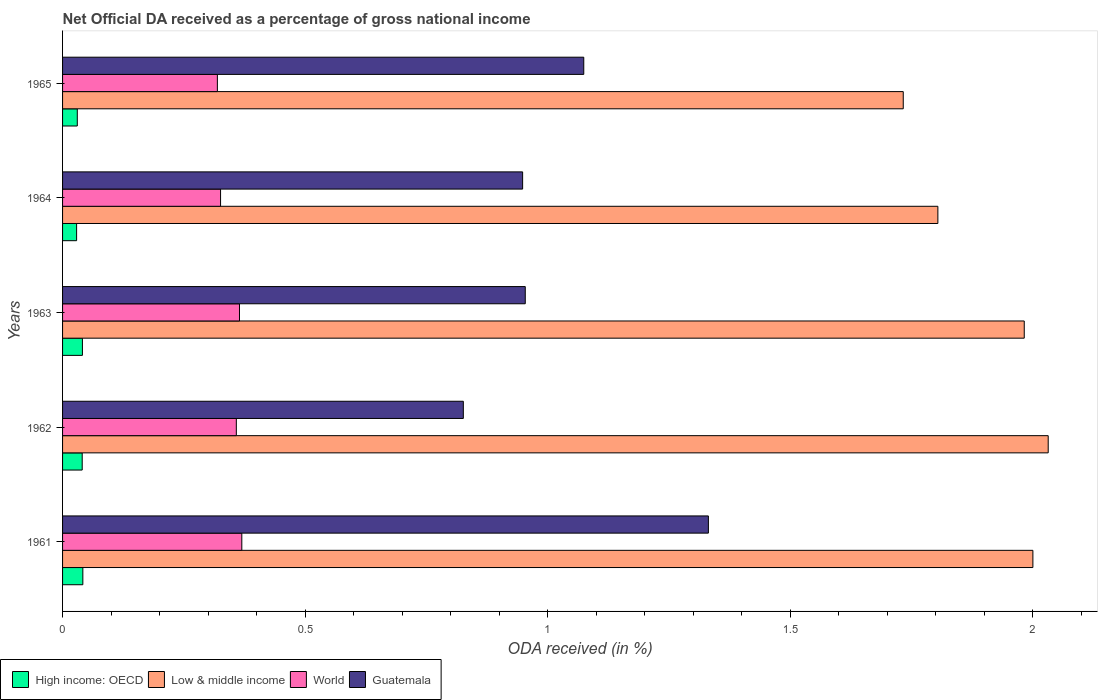How many bars are there on the 4th tick from the bottom?
Keep it short and to the point. 4. What is the label of the 5th group of bars from the top?
Your answer should be very brief. 1961. What is the net official DA received in High income: OECD in 1962?
Offer a very short reply. 0.04. Across all years, what is the maximum net official DA received in World?
Make the answer very short. 0.37. Across all years, what is the minimum net official DA received in Guatemala?
Ensure brevity in your answer.  0.83. In which year was the net official DA received in High income: OECD minimum?
Your answer should be very brief. 1964. What is the total net official DA received in High income: OECD in the graph?
Your answer should be compact. 0.18. What is the difference between the net official DA received in Guatemala in 1963 and that in 1965?
Give a very brief answer. -0.12. What is the difference between the net official DA received in Guatemala in 1962 and the net official DA received in World in 1965?
Your answer should be very brief. 0.51. What is the average net official DA received in World per year?
Your answer should be compact. 0.35. In the year 1964, what is the difference between the net official DA received in Guatemala and net official DA received in World?
Keep it short and to the point. 0.62. In how many years, is the net official DA received in Low & middle income greater than 0.8 %?
Keep it short and to the point. 5. What is the ratio of the net official DA received in High income: OECD in 1962 to that in 1965?
Make the answer very short. 1.33. Is the net official DA received in Guatemala in 1961 less than that in 1963?
Ensure brevity in your answer.  No. Is the difference between the net official DA received in Guatemala in 1961 and 1965 greater than the difference between the net official DA received in World in 1961 and 1965?
Make the answer very short. Yes. What is the difference between the highest and the second highest net official DA received in Low & middle income?
Ensure brevity in your answer.  0.03. What is the difference between the highest and the lowest net official DA received in Guatemala?
Provide a succinct answer. 0.51. Is it the case that in every year, the sum of the net official DA received in World and net official DA received in High income: OECD is greater than the sum of net official DA received in Guatemala and net official DA received in Low & middle income?
Your response must be concise. No. What does the 1st bar from the top in 1965 represents?
Offer a very short reply. Guatemala. What does the 4th bar from the bottom in 1964 represents?
Your answer should be compact. Guatemala. Is it the case that in every year, the sum of the net official DA received in World and net official DA received in Guatemala is greater than the net official DA received in High income: OECD?
Offer a terse response. Yes. Are all the bars in the graph horizontal?
Provide a short and direct response. Yes. How many years are there in the graph?
Your answer should be compact. 5. What is the difference between two consecutive major ticks on the X-axis?
Your answer should be very brief. 0.5. Are the values on the major ticks of X-axis written in scientific E-notation?
Offer a terse response. No. Does the graph contain any zero values?
Keep it short and to the point. No. Where does the legend appear in the graph?
Your response must be concise. Bottom left. How are the legend labels stacked?
Offer a terse response. Horizontal. What is the title of the graph?
Provide a succinct answer. Net Official DA received as a percentage of gross national income. Does "Tunisia" appear as one of the legend labels in the graph?
Provide a short and direct response. No. What is the label or title of the X-axis?
Your answer should be compact. ODA received (in %). What is the label or title of the Y-axis?
Keep it short and to the point. Years. What is the ODA received (in %) in High income: OECD in 1961?
Your answer should be very brief. 0.04. What is the ODA received (in %) in Low & middle income in 1961?
Provide a succinct answer. 2. What is the ODA received (in %) of World in 1961?
Your response must be concise. 0.37. What is the ODA received (in %) in Guatemala in 1961?
Ensure brevity in your answer.  1.33. What is the ODA received (in %) of High income: OECD in 1962?
Your response must be concise. 0.04. What is the ODA received (in %) in Low & middle income in 1962?
Ensure brevity in your answer.  2.03. What is the ODA received (in %) of World in 1962?
Your answer should be compact. 0.36. What is the ODA received (in %) of Guatemala in 1962?
Provide a succinct answer. 0.83. What is the ODA received (in %) of High income: OECD in 1963?
Give a very brief answer. 0.04. What is the ODA received (in %) of Low & middle income in 1963?
Provide a short and direct response. 1.98. What is the ODA received (in %) in World in 1963?
Make the answer very short. 0.36. What is the ODA received (in %) in Guatemala in 1963?
Give a very brief answer. 0.95. What is the ODA received (in %) in High income: OECD in 1964?
Give a very brief answer. 0.03. What is the ODA received (in %) of Low & middle income in 1964?
Ensure brevity in your answer.  1.8. What is the ODA received (in %) in World in 1964?
Make the answer very short. 0.33. What is the ODA received (in %) in Guatemala in 1964?
Offer a very short reply. 0.95. What is the ODA received (in %) of High income: OECD in 1965?
Make the answer very short. 0.03. What is the ODA received (in %) in Low & middle income in 1965?
Ensure brevity in your answer.  1.73. What is the ODA received (in %) of World in 1965?
Ensure brevity in your answer.  0.32. What is the ODA received (in %) of Guatemala in 1965?
Provide a short and direct response. 1.07. Across all years, what is the maximum ODA received (in %) in High income: OECD?
Your answer should be very brief. 0.04. Across all years, what is the maximum ODA received (in %) of Low & middle income?
Keep it short and to the point. 2.03. Across all years, what is the maximum ODA received (in %) in World?
Your response must be concise. 0.37. Across all years, what is the maximum ODA received (in %) in Guatemala?
Your answer should be very brief. 1.33. Across all years, what is the minimum ODA received (in %) of High income: OECD?
Offer a terse response. 0.03. Across all years, what is the minimum ODA received (in %) in Low & middle income?
Give a very brief answer. 1.73. Across all years, what is the minimum ODA received (in %) in World?
Keep it short and to the point. 0.32. Across all years, what is the minimum ODA received (in %) of Guatemala?
Your answer should be compact. 0.83. What is the total ODA received (in %) of High income: OECD in the graph?
Give a very brief answer. 0.18. What is the total ODA received (in %) of Low & middle income in the graph?
Offer a terse response. 9.55. What is the total ODA received (in %) in World in the graph?
Offer a terse response. 1.74. What is the total ODA received (in %) of Guatemala in the graph?
Provide a succinct answer. 5.13. What is the difference between the ODA received (in %) of High income: OECD in 1961 and that in 1962?
Ensure brevity in your answer.  0. What is the difference between the ODA received (in %) in Low & middle income in 1961 and that in 1962?
Offer a very short reply. -0.03. What is the difference between the ODA received (in %) in World in 1961 and that in 1962?
Ensure brevity in your answer.  0.01. What is the difference between the ODA received (in %) of Guatemala in 1961 and that in 1962?
Keep it short and to the point. 0.51. What is the difference between the ODA received (in %) in High income: OECD in 1961 and that in 1963?
Provide a succinct answer. 0. What is the difference between the ODA received (in %) of Low & middle income in 1961 and that in 1963?
Ensure brevity in your answer.  0.02. What is the difference between the ODA received (in %) in World in 1961 and that in 1963?
Your response must be concise. 0. What is the difference between the ODA received (in %) in Guatemala in 1961 and that in 1963?
Your answer should be compact. 0.38. What is the difference between the ODA received (in %) in High income: OECD in 1961 and that in 1964?
Make the answer very short. 0.01. What is the difference between the ODA received (in %) of Low & middle income in 1961 and that in 1964?
Provide a short and direct response. 0.2. What is the difference between the ODA received (in %) of World in 1961 and that in 1964?
Give a very brief answer. 0.04. What is the difference between the ODA received (in %) of Guatemala in 1961 and that in 1964?
Provide a succinct answer. 0.38. What is the difference between the ODA received (in %) in High income: OECD in 1961 and that in 1965?
Ensure brevity in your answer.  0.01. What is the difference between the ODA received (in %) of Low & middle income in 1961 and that in 1965?
Your answer should be compact. 0.27. What is the difference between the ODA received (in %) of World in 1961 and that in 1965?
Give a very brief answer. 0.05. What is the difference between the ODA received (in %) of Guatemala in 1961 and that in 1965?
Make the answer very short. 0.26. What is the difference between the ODA received (in %) in High income: OECD in 1962 and that in 1963?
Make the answer very short. -0. What is the difference between the ODA received (in %) in Low & middle income in 1962 and that in 1963?
Provide a succinct answer. 0.05. What is the difference between the ODA received (in %) of World in 1962 and that in 1963?
Offer a terse response. -0.01. What is the difference between the ODA received (in %) in Guatemala in 1962 and that in 1963?
Keep it short and to the point. -0.13. What is the difference between the ODA received (in %) in High income: OECD in 1962 and that in 1964?
Ensure brevity in your answer.  0.01. What is the difference between the ODA received (in %) of Low & middle income in 1962 and that in 1964?
Your answer should be compact. 0.23. What is the difference between the ODA received (in %) in World in 1962 and that in 1964?
Provide a short and direct response. 0.03. What is the difference between the ODA received (in %) of Guatemala in 1962 and that in 1964?
Provide a succinct answer. -0.12. What is the difference between the ODA received (in %) of High income: OECD in 1962 and that in 1965?
Keep it short and to the point. 0.01. What is the difference between the ODA received (in %) in Low & middle income in 1962 and that in 1965?
Your answer should be compact. 0.3. What is the difference between the ODA received (in %) of World in 1962 and that in 1965?
Give a very brief answer. 0.04. What is the difference between the ODA received (in %) of Guatemala in 1962 and that in 1965?
Your response must be concise. -0.25. What is the difference between the ODA received (in %) in High income: OECD in 1963 and that in 1964?
Provide a short and direct response. 0.01. What is the difference between the ODA received (in %) in Low & middle income in 1963 and that in 1964?
Your response must be concise. 0.18. What is the difference between the ODA received (in %) of World in 1963 and that in 1964?
Provide a short and direct response. 0.04. What is the difference between the ODA received (in %) of Guatemala in 1963 and that in 1964?
Offer a terse response. 0.01. What is the difference between the ODA received (in %) of High income: OECD in 1963 and that in 1965?
Offer a terse response. 0.01. What is the difference between the ODA received (in %) in Low & middle income in 1963 and that in 1965?
Your answer should be compact. 0.25. What is the difference between the ODA received (in %) of World in 1963 and that in 1965?
Give a very brief answer. 0.05. What is the difference between the ODA received (in %) in Guatemala in 1963 and that in 1965?
Your answer should be very brief. -0.12. What is the difference between the ODA received (in %) of High income: OECD in 1964 and that in 1965?
Give a very brief answer. -0. What is the difference between the ODA received (in %) of Low & middle income in 1964 and that in 1965?
Make the answer very short. 0.07. What is the difference between the ODA received (in %) in World in 1964 and that in 1965?
Provide a succinct answer. 0.01. What is the difference between the ODA received (in %) in Guatemala in 1964 and that in 1965?
Offer a terse response. -0.13. What is the difference between the ODA received (in %) of High income: OECD in 1961 and the ODA received (in %) of Low & middle income in 1962?
Provide a short and direct response. -1.99. What is the difference between the ODA received (in %) of High income: OECD in 1961 and the ODA received (in %) of World in 1962?
Your answer should be very brief. -0.32. What is the difference between the ODA received (in %) of High income: OECD in 1961 and the ODA received (in %) of Guatemala in 1962?
Ensure brevity in your answer.  -0.78. What is the difference between the ODA received (in %) of Low & middle income in 1961 and the ODA received (in %) of World in 1962?
Keep it short and to the point. 1.64. What is the difference between the ODA received (in %) of Low & middle income in 1961 and the ODA received (in %) of Guatemala in 1962?
Make the answer very short. 1.17. What is the difference between the ODA received (in %) of World in 1961 and the ODA received (in %) of Guatemala in 1962?
Provide a succinct answer. -0.46. What is the difference between the ODA received (in %) of High income: OECD in 1961 and the ODA received (in %) of Low & middle income in 1963?
Provide a short and direct response. -1.94. What is the difference between the ODA received (in %) of High income: OECD in 1961 and the ODA received (in %) of World in 1963?
Offer a very short reply. -0.32. What is the difference between the ODA received (in %) in High income: OECD in 1961 and the ODA received (in %) in Guatemala in 1963?
Provide a succinct answer. -0.91. What is the difference between the ODA received (in %) in Low & middle income in 1961 and the ODA received (in %) in World in 1963?
Provide a succinct answer. 1.64. What is the difference between the ODA received (in %) of Low & middle income in 1961 and the ODA received (in %) of Guatemala in 1963?
Your answer should be compact. 1.05. What is the difference between the ODA received (in %) in World in 1961 and the ODA received (in %) in Guatemala in 1963?
Provide a succinct answer. -0.58. What is the difference between the ODA received (in %) of High income: OECD in 1961 and the ODA received (in %) of Low & middle income in 1964?
Keep it short and to the point. -1.76. What is the difference between the ODA received (in %) of High income: OECD in 1961 and the ODA received (in %) of World in 1964?
Your answer should be very brief. -0.28. What is the difference between the ODA received (in %) in High income: OECD in 1961 and the ODA received (in %) in Guatemala in 1964?
Offer a very short reply. -0.91. What is the difference between the ODA received (in %) in Low & middle income in 1961 and the ODA received (in %) in World in 1964?
Give a very brief answer. 1.67. What is the difference between the ODA received (in %) in Low & middle income in 1961 and the ODA received (in %) in Guatemala in 1964?
Your answer should be very brief. 1.05. What is the difference between the ODA received (in %) in World in 1961 and the ODA received (in %) in Guatemala in 1964?
Make the answer very short. -0.58. What is the difference between the ODA received (in %) in High income: OECD in 1961 and the ODA received (in %) in Low & middle income in 1965?
Offer a very short reply. -1.69. What is the difference between the ODA received (in %) of High income: OECD in 1961 and the ODA received (in %) of World in 1965?
Keep it short and to the point. -0.28. What is the difference between the ODA received (in %) of High income: OECD in 1961 and the ODA received (in %) of Guatemala in 1965?
Offer a terse response. -1.03. What is the difference between the ODA received (in %) in Low & middle income in 1961 and the ODA received (in %) in World in 1965?
Ensure brevity in your answer.  1.68. What is the difference between the ODA received (in %) of Low & middle income in 1961 and the ODA received (in %) of Guatemala in 1965?
Offer a very short reply. 0.93. What is the difference between the ODA received (in %) in World in 1961 and the ODA received (in %) in Guatemala in 1965?
Provide a short and direct response. -0.7. What is the difference between the ODA received (in %) of High income: OECD in 1962 and the ODA received (in %) of Low & middle income in 1963?
Offer a very short reply. -1.94. What is the difference between the ODA received (in %) of High income: OECD in 1962 and the ODA received (in %) of World in 1963?
Give a very brief answer. -0.32. What is the difference between the ODA received (in %) of High income: OECD in 1962 and the ODA received (in %) of Guatemala in 1963?
Provide a short and direct response. -0.91. What is the difference between the ODA received (in %) in Low & middle income in 1962 and the ODA received (in %) in World in 1963?
Your response must be concise. 1.67. What is the difference between the ODA received (in %) of Low & middle income in 1962 and the ODA received (in %) of Guatemala in 1963?
Provide a succinct answer. 1.08. What is the difference between the ODA received (in %) in World in 1962 and the ODA received (in %) in Guatemala in 1963?
Offer a terse response. -0.6. What is the difference between the ODA received (in %) in High income: OECD in 1962 and the ODA received (in %) in Low & middle income in 1964?
Make the answer very short. -1.76. What is the difference between the ODA received (in %) of High income: OECD in 1962 and the ODA received (in %) of World in 1964?
Provide a short and direct response. -0.29. What is the difference between the ODA received (in %) in High income: OECD in 1962 and the ODA received (in %) in Guatemala in 1964?
Ensure brevity in your answer.  -0.91. What is the difference between the ODA received (in %) of Low & middle income in 1962 and the ODA received (in %) of World in 1964?
Offer a terse response. 1.71. What is the difference between the ODA received (in %) of Low & middle income in 1962 and the ODA received (in %) of Guatemala in 1964?
Give a very brief answer. 1.08. What is the difference between the ODA received (in %) of World in 1962 and the ODA received (in %) of Guatemala in 1964?
Offer a very short reply. -0.59. What is the difference between the ODA received (in %) of High income: OECD in 1962 and the ODA received (in %) of Low & middle income in 1965?
Your answer should be compact. -1.69. What is the difference between the ODA received (in %) in High income: OECD in 1962 and the ODA received (in %) in World in 1965?
Your response must be concise. -0.28. What is the difference between the ODA received (in %) in High income: OECD in 1962 and the ODA received (in %) in Guatemala in 1965?
Provide a succinct answer. -1.03. What is the difference between the ODA received (in %) of Low & middle income in 1962 and the ODA received (in %) of World in 1965?
Make the answer very short. 1.71. What is the difference between the ODA received (in %) of Low & middle income in 1962 and the ODA received (in %) of Guatemala in 1965?
Offer a very short reply. 0.96. What is the difference between the ODA received (in %) of World in 1962 and the ODA received (in %) of Guatemala in 1965?
Provide a short and direct response. -0.72. What is the difference between the ODA received (in %) in High income: OECD in 1963 and the ODA received (in %) in Low & middle income in 1964?
Your response must be concise. -1.76. What is the difference between the ODA received (in %) in High income: OECD in 1963 and the ODA received (in %) in World in 1964?
Provide a succinct answer. -0.28. What is the difference between the ODA received (in %) in High income: OECD in 1963 and the ODA received (in %) in Guatemala in 1964?
Keep it short and to the point. -0.91. What is the difference between the ODA received (in %) of Low & middle income in 1963 and the ODA received (in %) of World in 1964?
Give a very brief answer. 1.66. What is the difference between the ODA received (in %) in Low & middle income in 1963 and the ODA received (in %) in Guatemala in 1964?
Your response must be concise. 1.03. What is the difference between the ODA received (in %) of World in 1963 and the ODA received (in %) of Guatemala in 1964?
Offer a terse response. -0.58. What is the difference between the ODA received (in %) in High income: OECD in 1963 and the ODA received (in %) in Low & middle income in 1965?
Your answer should be compact. -1.69. What is the difference between the ODA received (in %) in High income: OECD in 1963 and the ODA received (in %) in World in 1965?
Your answer should be compact. -0.28. What is the difference between the ODA received (in %) in High income: OECD in 1963 and the ODA received (in %) in Guatemala in 1965?
Offer a very short reply. -1.03. What is the difference between the ODA received (in %) of Low & middle income in 1963 and the ODA received (in %) of World in 1965?
Your response must be concise. 1.66. What is the difference between the ODA received (in %) in Low & middle income in 1963 and the ODA received (in %) in Guatemala in 1965?
Ensure brevity in your answer.  0.91. What is the difference between the ODA received (in %) of World in 1963 and the ODA received (in %) of Guatemala in 1965?
Provide a succinct answer. -0.71. What is the difference between the ODA received (in %) of High income: OECD in 1964 and the ODA received (in %) of Low & middle income in 1965?
Provide a short and direct response. -1.7. What is the difference between the ODA received (in %) in High income: OECD in 1964 and the ODA received (in %) in World in 1965?
Offer a terse response. -0.29. What is the difference between the ODA received (in %) of High income: OECD in 1964 and the ODA received (in %) of Guatemala in 1965?
Offer a terse response. -1.05. What is the difference between the ODA received (in %) in Low & middle income in 1964 and the ODA received (in %) in World in 1965?
Ensure brevity in your answer.  1.49. What is the difference between the ODA received (in %) of Low & middle income in 1964 and the ODA received (in %) of Guatemala in 1965?
Offer a very short reply. 0.73. What is the difference between the ODA received (in %) of World in 1964 and the ODA received (in %) of Guatemala in 1965?
Keep it short and to the point. -0.75. What is the average ODA received (in %) in High income: OECD per year?
Ensure brevity in your answer.  0.04. What is the average ODA received (in %) in Low & middle income per year?
Ensure brevity in your answer.  1.91. What is the average ODA received (in %) of World per year?
Keep it short and to the point. 0.35. What is the average ODA received (in %) of Guatemala per year?
Your answer should be very brief. 1.03. In the year 1961, what is the difference between the ODA received (in %) in High income: OECD and ODA received (in %) in Low & middle income?
Provide a succinct answer. -1.96. In the year 1961, what is the difference between the ODA received (in %) in High income: OECD and ODA received (in %) in World?
Make the answer very short. -0.33. In the year 1961, what is the difference between the ODA received (in %) in High income: OECD and ODA received (in %) in Guatemala?
Keep it short and to the point. -1.29. In the year 1961, what is the difference between the ODA received (in %) in Low & middle income and ODA received (in %) in World?
Your response must be concise. 1.63. In the year 1961, what is the difference between the ODA received (in %) of Low & middle income and ODA received (in %) of Guatemala?
Provide a short and direct response. 0.67. In the year 1961, what is the difference between the ODA received (in %) in World and ODA received (in %) in Guatemala?
Provide a short and direct response. -0.96. In the year 1962, what is the difference between the ODA received (in %) in High income: OECD and ODA received (in %) in Low & middle income?
Make the answer very short. -1.99. In the year 1962, what is the difference between the ODA received (in %) of High income: OECD and ODA received (in %) of World?
Your response must be concise. -0.32. In the year 1962, what is the difference between the ODA received (in %) of High income: OECD and ODA received (in %) of Guatemala?
Make the answer very short. -0.79. In the year 1962, what is the difference between the ODA received (in %) in Low & middle income and ODA received (in %) in World?
Your answer should be very brief. 1.67. In the year 1962, what is the difference between the ODA received (in %) of Low & middle income and ODA received (in %) of Guatemala?
Offer a very short reply. 1.21. In the year 1962, what is the difference between the ODA received (in %) of World and ODA received (in %) of Guatemala?
Your response must be concise. -0.47. In the year 1963, what is the difference between the ODA received (in %) of High income: OECD and ODA received (in %) of Low & middle income?
Provide a short and direct response. -1.94. In the year 1963, what is the difference between the ODA received (in %) of High income: OECD and ODA received (in %) of World?
Ensure brevity in your answer.  -0.32. In the year 1963, what is the difference between the ODA received (in %) of High income: OECD and ODA received (in %) of Guatemala?
Ensure brevity in your answer.  -0.91. In the year 1963, what is the difference between the ODA received (in %) in Low & middle income and ODA received (in %) in World?
Offer a very short reply. 1.62. In the year 1963, what is the difference between the ODA received (in %) in Low & middle income and ODA received (in %) in Guatemala?
Make the answer very short. 1.03. In the year 1963, what is the difference between the ODA received (in %) in World and ODA received (in %) in Guatemala?
Offer a very short reply. -0.59. In the year 1964, what is the difference between the ODA received (in %) of High income: OECD and ODA received (in %) of Low & middle income?
Your answer should be compact. -1.78. In the year 1964, what is the difference between the ODA received (in %) in High income: OECD and ODA received (in %) in World?
Offer a terse response. -0.3. In the year 1964, what is the difference between the ODA received (in %) of High income: OECD and ODA received (in %) of Guatemala?
Offer a terse response. -0.92. In the year 1964, what is the difference between the ODA received (in %) of Low & middle income and ODA received (in %) of World?
Give a very brief answer. 1.48. In the year 1964, what is the difference between the ODA received (in %) in Low & middle income and ODA received (in %) in Guatemala?
Your answer should be compact. 0.86. In the year 1964, what is the difference between the ODA received (in %) of World and ODA received (in %) of Guatemala?
Your answer should be compact. -0.62. In the year 1965, what is the difference between the ODA received (in %) in High income: OECD and ODA received (in %) in Low & middle income?
Keep it short and to the point. -1.7. In the year 1965, what is the difference between the ODA received (in %) in High income: OECD and ODA received (in %) in World?
Give a very brief answer. -0.29. In the year 1965, what is the difference between the ODA received (in %) of High income: OECD and ODA received (in %) of Guatemala?
Your response must be concise. -1.04. In the year 1965, what is the difference between the ODA received (in %) in Low & middle income and ODA received (in %) in World?
Provide a short and direct response. 1.41. In the year 1965, what is the difference between the ODA received (in %) in Low & middle income and ODA received (in %) in Guatemala?
Give a very brief answer. 0.66. In the year 1965, what is the difference between the ODA received (in %) in World and ODA received (in %) in Guatemala?
Ensure brevity in your answer.  -0.76. What is the ratio of the ODA received (in %) in High income: OECD in 1961 to that in 1962?
Your answer should be very brief. 1.03. What is the ratio of the ODA received (in %) of Low & middle income in 1961 to that in 1962?
Your answer should be compact. 0.98. What is the ratio of the ODA received (in %) of World in 1961 to that in 1962?
Ensure brevity in your answer.  1.03. What is the ratio of the ODA received (in %) of Guatemala in 1961 to that in 1962?
Your answer should be very brief. 1.61. What is the ratio of the ODA received (in %) in High income: OECD in 1961 to that in 1963?
Offer a terse response. 1.02. What is the ratio of the ODA received (in %) in Low & middle income in 1961 to that in 1963?
Keep it short and to the point. 1.01. What is the ratio of the ODA received (in %) of World in 1961 to that in 1963?
Offer a very short reply. 1.01. What is the ratio of the ODA received (in %) of Guatemala in 1961 to that in 1963?
Your answer should be very brief. 1.4. What is the ratio of the ODA received (in %) in High income: OECD in 1961 to that in 1964?
Ensure brevity in your answer.  1.44. What is the ratio of the ODA received (in %) of Low & middle income in 1961 to that in 1964?
Offer a very short reply. 1.11. What is the ratio of the ODA received (in %) in World in 1961 to that in 1964?
Make the answer very short. 1.13. What is the ratio of the ODA received (in %) of Guatemala in 1961 to that in 1964?
Offer a terse response. 1.4. What is the ratio of the ODA received (in %) in High income: OECD in 1961 to that in 1965?
Provide a short and direct response. 1.38. What is the ratio of the ODA received (in %) of Low & middle income in 1961 to that in 1965?
Offer a very short reply. 1.15. What is the ratio of the ODA received (in %) of World in 1961 to that in 1965?
Your answer should be compact. 1.16. What is the ratio of the ODA received (in %) in Guatemala in 1961 to that in 1965?
Ensure brevity in your answer.  1.24. What is the ratio of the ODA received (in %) in Low & middle income in 1962 to that in 1963?
Provide a short and direct response. 1.02. What is the ratio of the ODA received (in %) of World in 1962 to that in 1963?
Provide a short and direct response. 0.98. What is the ratio of the ODA received (in %) in Guatemala in 1962 to that in 1963?
Your response must be concise. 0.87. What is the ratio of the ODA received (in %) of High income: OECD in 1962 to that in 1964?
Your response must be concise. 1.4. What is the ratio of the ODA received (in %) in Low & middle income in 1962 to that in 1964?
Provide a short and direct response. 1.13. What is the ratio of the ODA received (in %) in World in 1962 to that in 1964?
Ensure brevity in your answer.  1.1. What is the ratio of the ODA received (in %) in Guatemala in 1962 to that in 1964?
Offer a terse response. 0.87. What is the ratio of the ODA received (in %) in High income: OECD in 1962 to that in 1965?
Provide a short and direct response. 1.33. What is the ratio of the ODA received (in %) of Low & middle income in 1962 to that in 1965?
Make the answer very short. 1.17. What is the ratio of the ODA received (in %) in World in 1962 to that in 1965?
Offer a very short reply. 1.12. What is the ratio of the ODA received (in %) in Guatemala in 1962 to that in 1965?
Ensure brevity in your answer.  0.77. What is the ratio of the ODA received (in %) of High income: OECD in 1963 to that in 1964?
Provide a short and direct response. 1.41. What is the ratio of the ODA received (in %) in Low & middle income in 1963 to that in 1964?
Provide a succinct answer. 1.1. What is the ratio of the ODA received (in %) of World in 1963 to that in 1964?
Provide a short and direct response. 1.12. What is the ratio of the ODA received (in %) of High income: OECD in 1963 to that in 1965?
Your response must be concise. 1.35. What is the ratio of the ODA received (in %) of Low & middle income in 1963 to that in 1965?
Offer a very short reply. 1.14. What is the ratio of the ODA received (in %) of World in 1963 to that in 1965?
Make the answer very short. 1.14. What is the ratio of the ODA received (in %) in Guatemala in 1963 to that in 1965?
Your response must be concise. 0.89. What is the ratio of the ODA received (in %) in High income: OECD in 1964 to that in 1965?
Offer a terse response. 0.95. What is the ratio of the ODA received (in %) of Low & middle income in 1964 to that in 1965?
Keep it short and to the point. 1.04. What is the ratio of the ODA received (in %) in World in 1964 to that in 1965?
Provide a succinct answer. 1.02. What is the ratio of the ODA received (in %) of Guatemala in 1964 to that in 1965?
Ensure brevity in your answer.  0.88. What is the difference between the highest and the second highest ODA received (in %) of High income: OECD?
Give a very brief answer. 0. What is the difference between the highest and the second highest ODA received (in %) in Low & middle income?
Offer a very short reply. 0.03. What is the difference between the highest and the second highest ODA received (in %) of World?
Give a very brief answer. 0. What is the difference between the highest and the second highest ODA received (in %) in Guatemala?
Keep it short and to the point. 0.26. What is the difference between the highest and the lowest ODA received (in %) of High income: OECD?
Ensure brevity in your answer.  0.01. What is the difference between the highest and the lowest ODA received (in %) in Low & middle income?
Your answer should be compact. 0.3. What is the difference between the highest and the lowest ODA received (in %) in World?
Offer a terse response. 0.05. What is the difference between the highest and the lowest ODA received (in %) in Guatemala?
Ensure brevity in your answer.  0.51. 